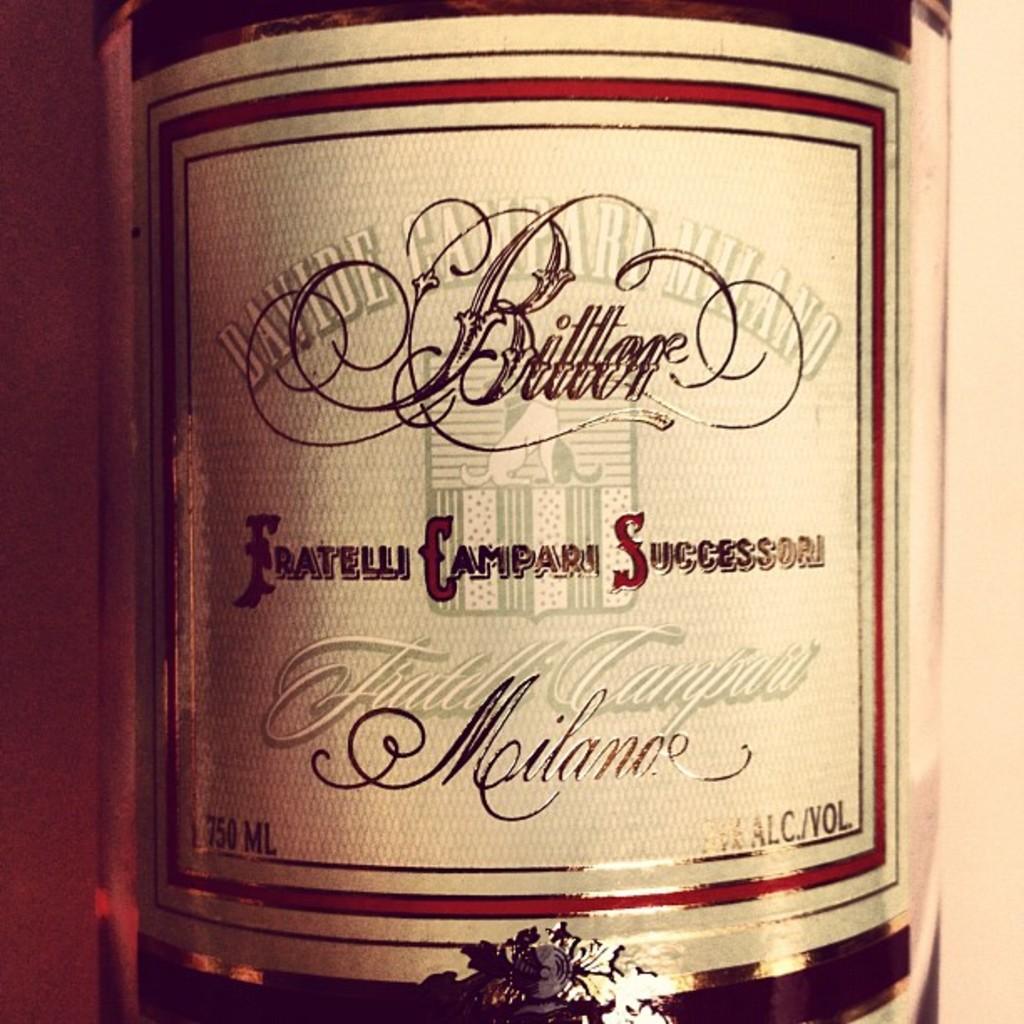How many milliliters is in this container?
Offer a terse response. 750. Is this bitter?
Your answer should be compact. Yes. 